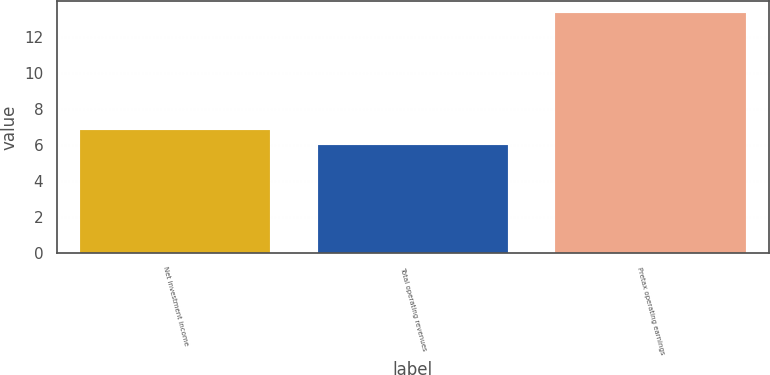<chart> <loc_0><loc_0><loc_500><loc_500><bar_chart><fcel>Net investment income<fcel>Total operating revenues<fcel>Pretax operating earnings<nl><fcel>6.8<fcel>6<fcel>13.3<nl></chart> 